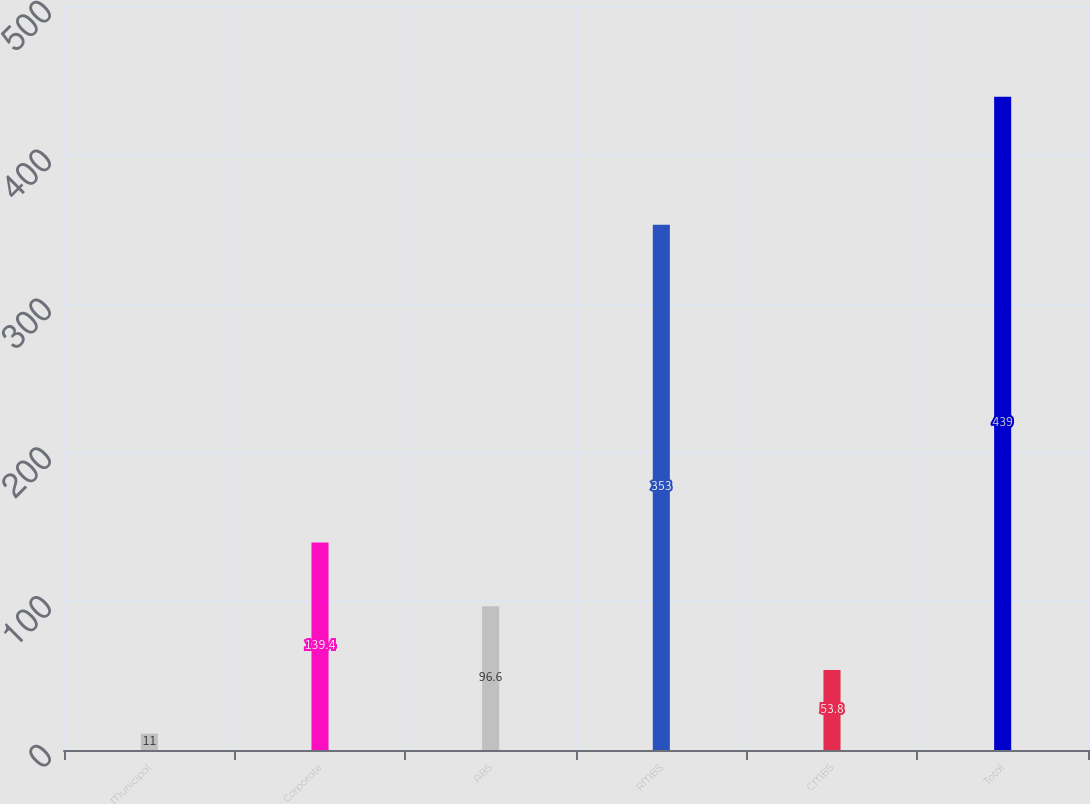Convert chart. <chart><loc_0><loc_0><loc_500><loc_500><bar_chart><fcel>Municipal<fcel>Corporate<fcel>ABS<fcel>RMBS<fcel>CMBS<fcel>Total<nl><fcel>11<fcel>139.4<fcel>96.6<fcel>353<fcel>53.8<fcel>439<nl></chart> 